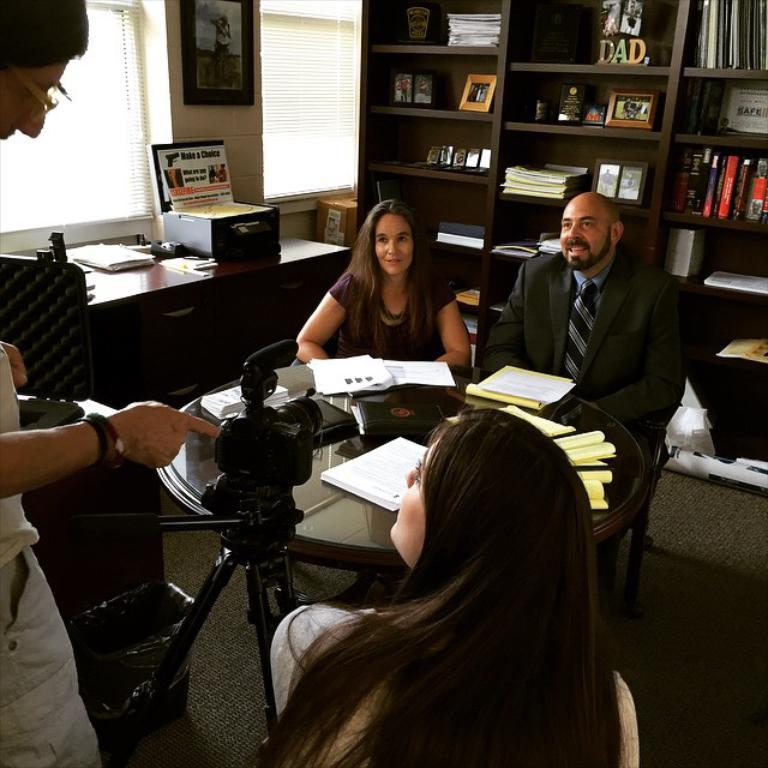<image>
Offer a succinct explanation of the picture presented. people doing an interview with a sign behind them stating make a choice 